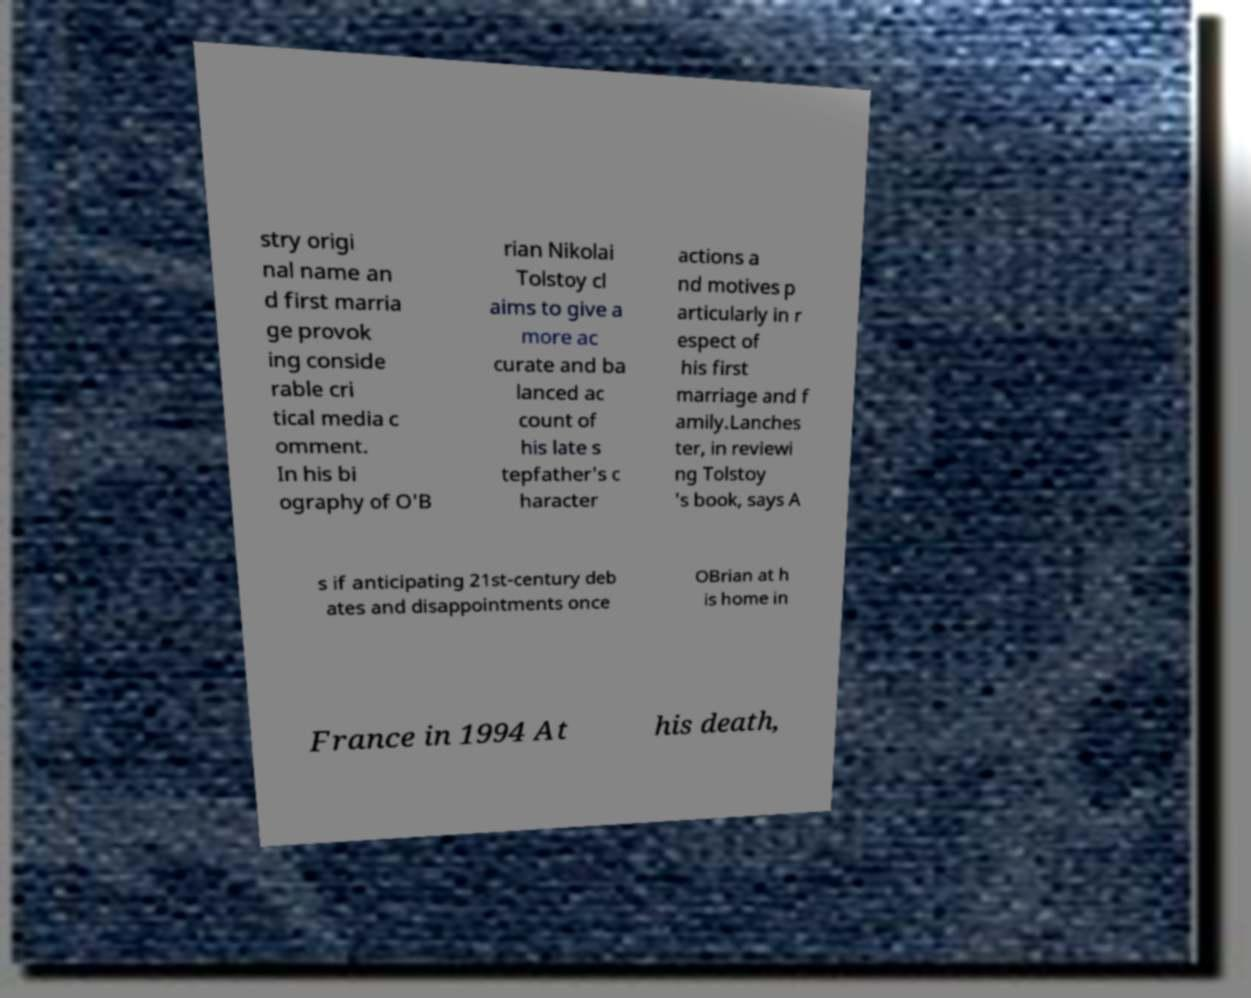Please read and relay the text visible in this image. What does it say? stry origi nal name an d first marria ge provok ing conside rable cri tical media c omment. In his bi ography of O'B rian Nikolai Tolstoy cl aims to give a more ac curate and ba lanced ac count of his late s tepfather's c haracter actions a nd motives p articularly in r espect of his first marriage and f amily.Lanches ter, in reviewi ng Tolstoy 's book, says A s if anticipating 21st-century deb ates and disappointments once OBrian at h is home in France in 1994 At his death, 